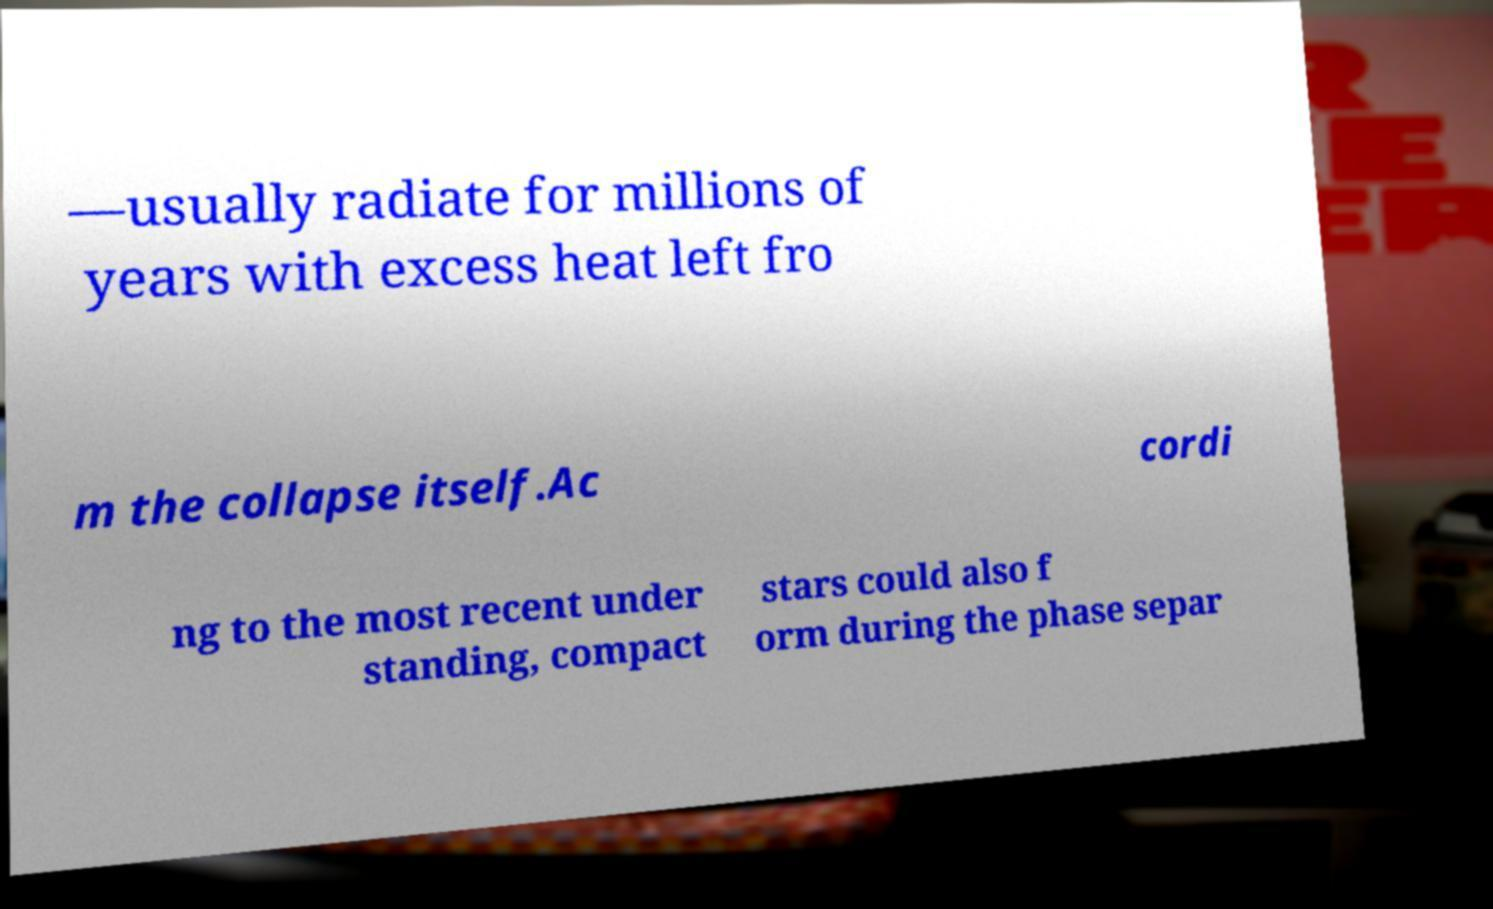Could you assist in decoding the text presented in this image and type it out clearly? —usually radiate for millions of years with excess heat left fro m the collapse itself.Ac cordi ng to the most recent under standing, compact stars could also f orm during the phase separ 